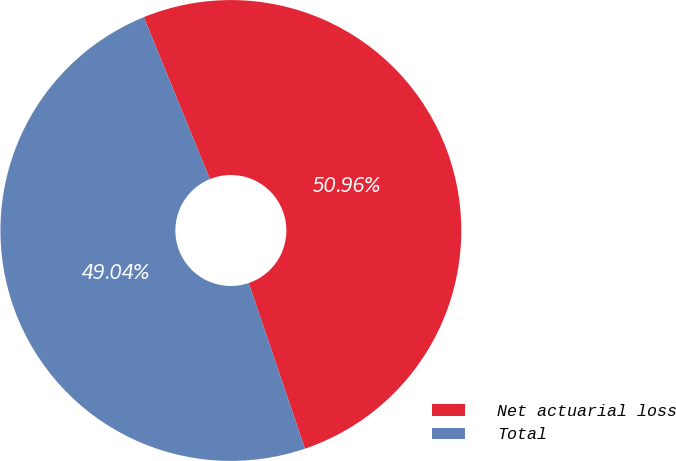Convert chart. <chart><loc_0><loc_0><loc_500><loc_500><pie_chart><fcel>Net actuarial loss<fcel>Total<nl><fcel>50.96%<fcel>49.04%<nl></chart> 